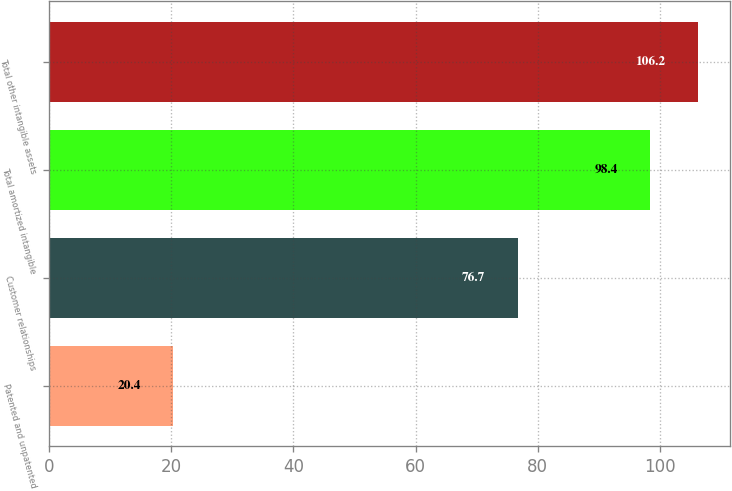Convert chart to OTSL. <chart><loc_0><loc_0><loc_500><loc_500><bar_chart><fcel>Patented and unpatented<fcel>Customer relationships<fcel>Total amortized intangible<fcel>Total other intangible assets<nl><fcel>20.4<fcel>76.7<fcel>98.4<fcel>106.2<nl></chart> 